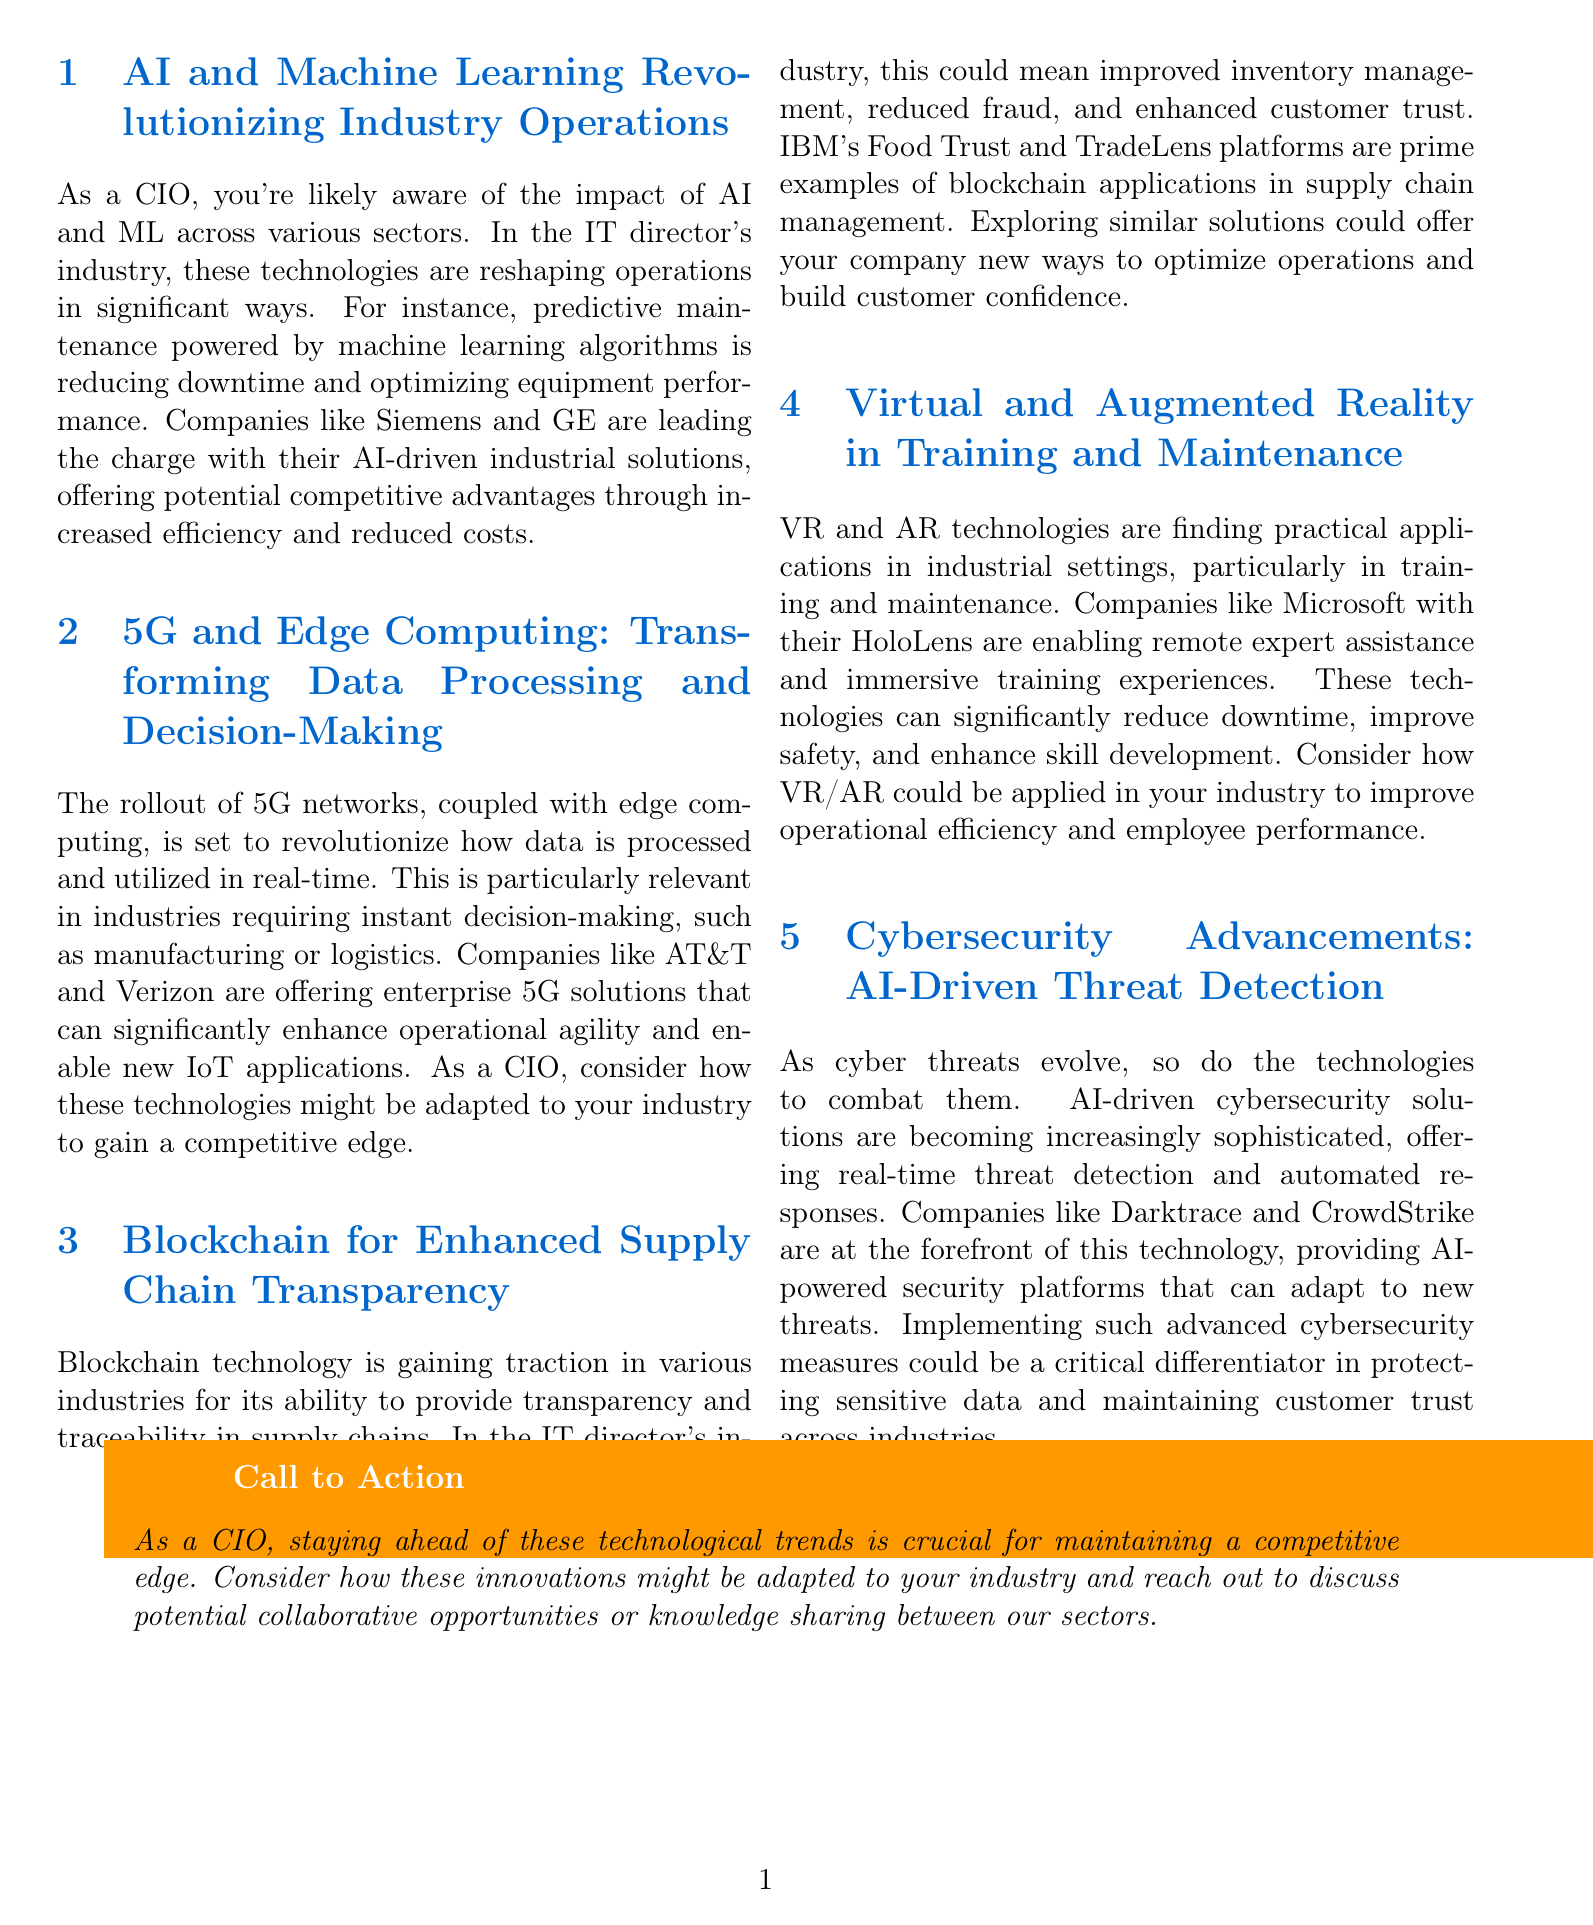What is the first technology discussed in the newsletter? The first technology mentioned in the newsletter is AI and Machine Learning, which is highlighted in the first section.
Answer: AI and Machine Learning Which companies are leading the charge in AI-driven industrial solutions? Siemens and GE are specifically mentioned as leaders in AI-driven solutions within the content of the newsletter.
Answer: Siemens and GE What kind of maintenance is improved by machine learning algorithms? The newsletter states that machine learning algorithms are used for predictive maintenance to optimize equipment performance.
Answer: Predictive maintenance Which technology is mentioned as transforming data processing and decision-making? The newsletter discusses that the rollout of 5G networks and edge computing is set to transform data processing and decision-making.
Answer: 5G networks and edge computing What platform is cited as an example of blockchain applications in supply chain management? IBM's Food Trust and TradeLens platforms are specifically cited as notable examples of blockchain applications in supply chain management.
Answer: IBM's Food Trust and TradeLens How are VR and AR technologies utilized according to the newsletter? The newsletter indicates that VR and AR technologies are used for training and maintenance in industrial settings.
Answer: Training and maintenance What is the focus of AI-driven cybersecurity solutions? AI-driven cybersecurity solutions primarily focus on real-time threat detection and automated responses, as stated in the newsletter.
Answer: Real-time threat detection and automated responses What is the call to action for CIOs in the newsletter? The newsletter's call to action suggests that CIOs consider how technological trends might be adapted to their industry and reach out for potential collaborations.
Answer: Consider adaptations and collaborations 